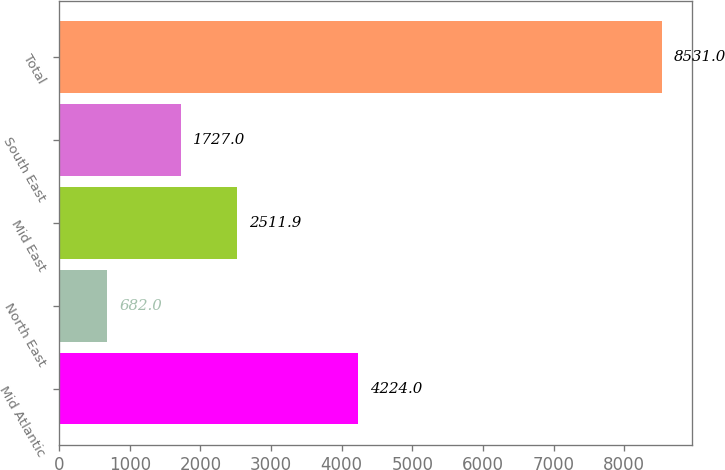Convert chart to OTSL. <chart><loc_0><loc_0><loc_500><loc_500><bar_chart><fcel>Mid Atlantic<fcel>North East<fcel>Mid East<fcel>South East<fcel>Total<nl><fcel>4224<fcel>682<fcel>2511.9<fcel>1727<fcel>8531<nl></chart> 